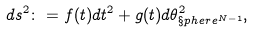<formula> <loc_0><loc_0><loc_500><loc_500>d s ^ { 2 } \colon = f ( t ) d t ^ { 2 } + g ( t ) d \theta _ { \S p h e r e ^ { N - 1 } } ^ { 2 } ,</formula> 